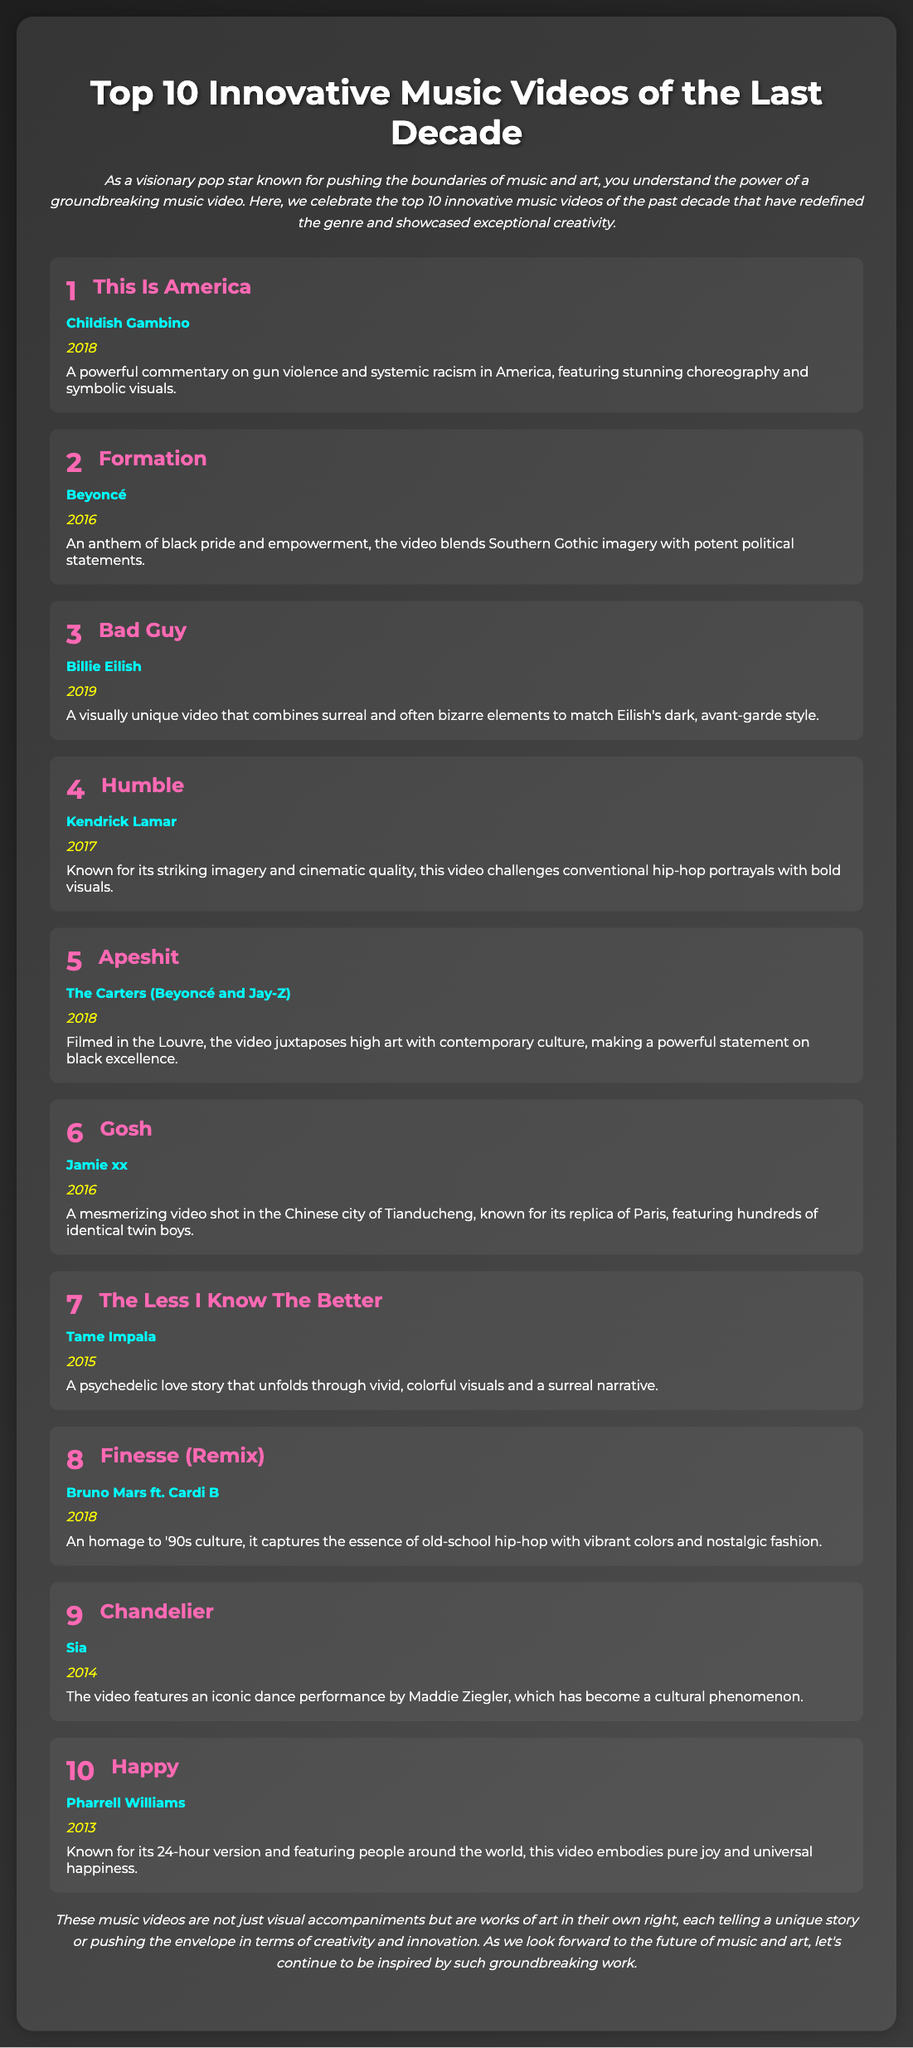What is the title of the most innovative music video? The title of the most innovative music video is "This Is America."
Answer: This Is America Who is the artist of the video ranked second? The artist of the video ranked second is Beyoncé.
Answer: Beyoncé What year was "Chandelier" released? "Chandelier" was released in 2014.
Answer: 2014 Which video features a commentary on gun violence? The video that features a commentary on gun violence is "This Is America."
Answer: This Is America How many videos on the list were released in 2018? There are four videos on the list that were released in 2018.
Answer: 4 Which music video is known for its iconic dance performance? The music video known for its iconic dance performance is "Chandelier."
Answer: Chandelier What imagery does the video "Formation" blend? "Formation" blends Southern Gothic imagery with potent political statements.
Answer: Southern Gothic imagery Which video was filmed in the Louvre? The video filmed in the Louvre is "Apeshit."
Answer: Apeshit What is a common theme of the top 10 innovative music videos? A common theme is exceptional creativity and pushing boundaries.
Answer: Exceptional creativity 